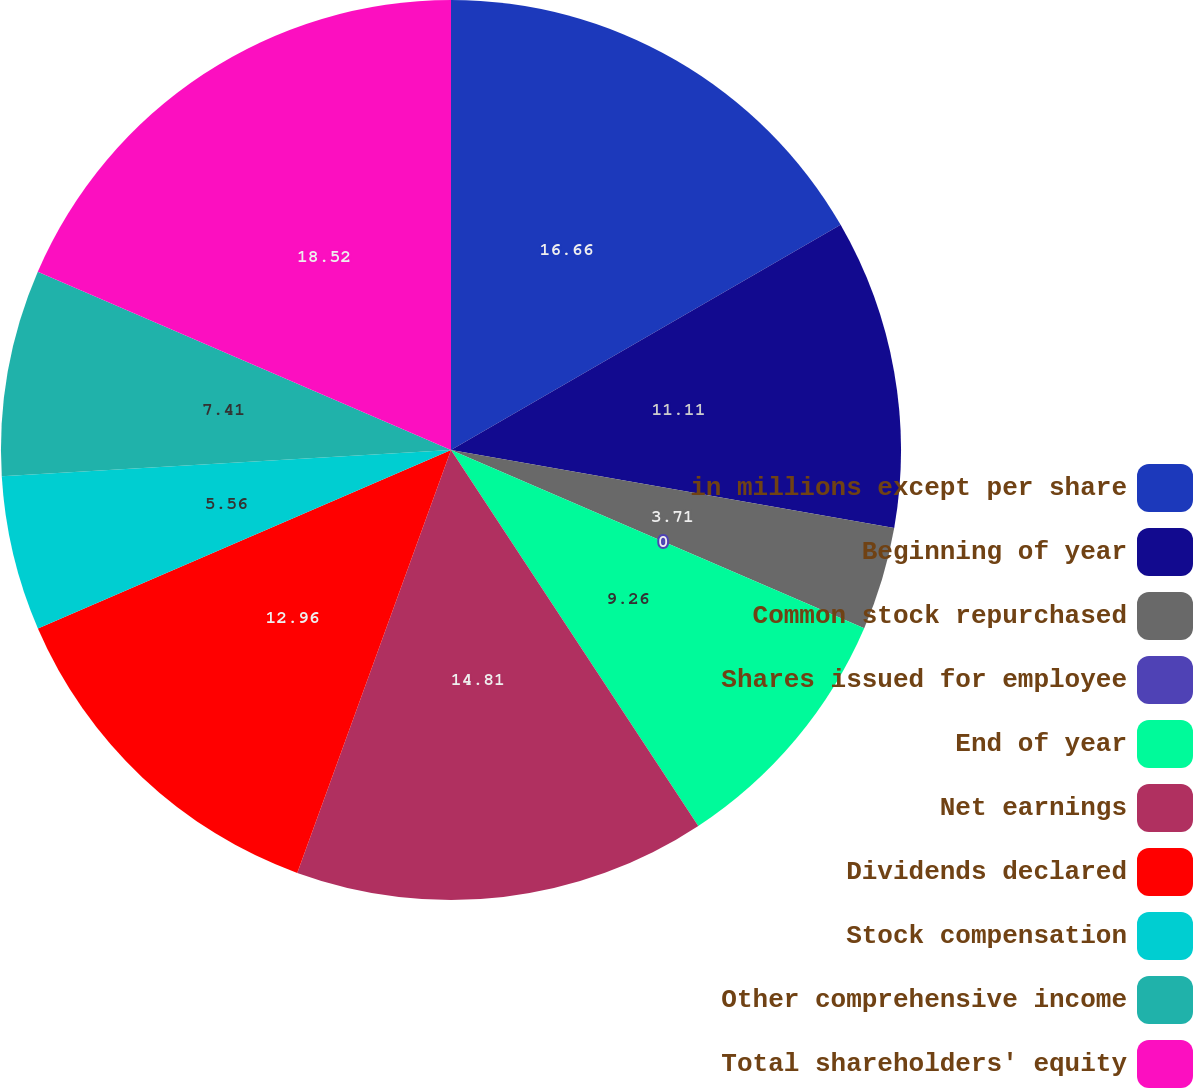Convert chart to OTSL. <chart><loc_0><loc_0><loc_500><loc_500><pie_chart><fcel>in millions except per share<fcel>Beginning of year<fcel>Common stock repurchased<fcel>Shares issued for employee<fcel>End of year<fcel>Net earnings<fcel>Dividends declared<fcel>Stock compensation<fcel>Other comprehensive income<fcel>Total shareholders' equity<nl><fcel>16.66%<fcel>11.11%<fcel>3.71%<fcel>0.0%<fcel>9.26%<fcel>14.81%<fcel>12.96%<fcel>5.56%<fcel>7.41%<fcel>18.52%<nl></chart> 